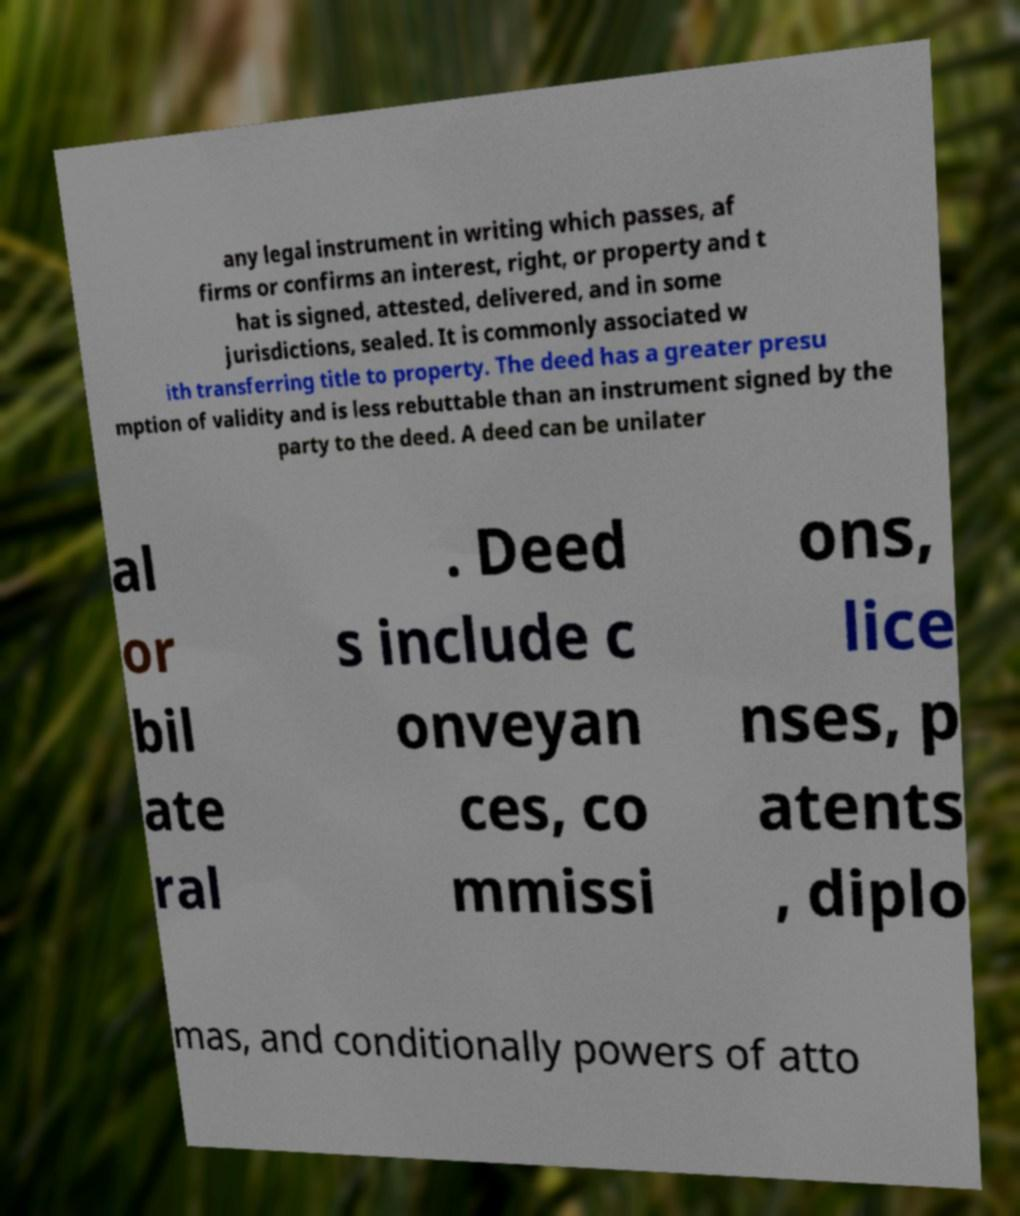Could you assist in decoding the text presented in this image and type it out clearly? any legal instrument in writing which passes, af firms or confirms an interest, right, or property and t hat is signed, attested, delivered, and in some jurisdictions, sealed. It is commonly associated w ith transferring title to property. The deed has a greater presu mption of validity and is less rebuttable than an instrument signed by the party to the deed. A deed can be unilater al or bil ate ral . Deed s include c onveyan ces, co mmissi ons, lice nses, p atents , diplo mas, and conditionally powers of atto 